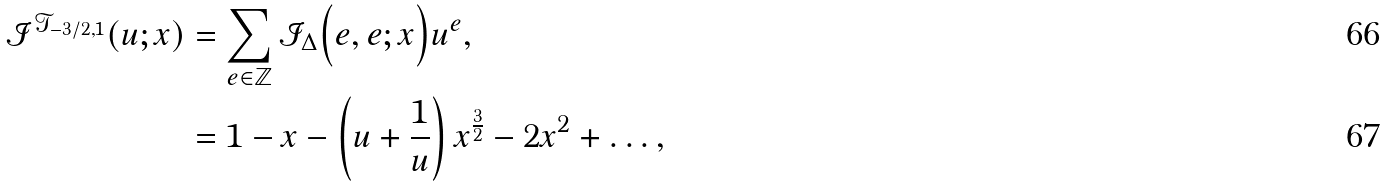<formula> <loc_0><loc_0><loc_500><loc_500>\mathcal { I } ^ { \mathcal { T } _ { - 3 / 2 , 1 } } ( u ; x ) & = \sum _ { e \in \mathbb { Z } } \mathcal { I } _ { \Delta } \Big { ( } e , e ; x \Big { ) } u ^ { e } , \\ & = 1 - x - \left ( u + \frac { 1 } { u } \right ) x ^ { \frac { 3 } { 2 } } - 2 x ^ { 2 } + \dots ,</formula> 